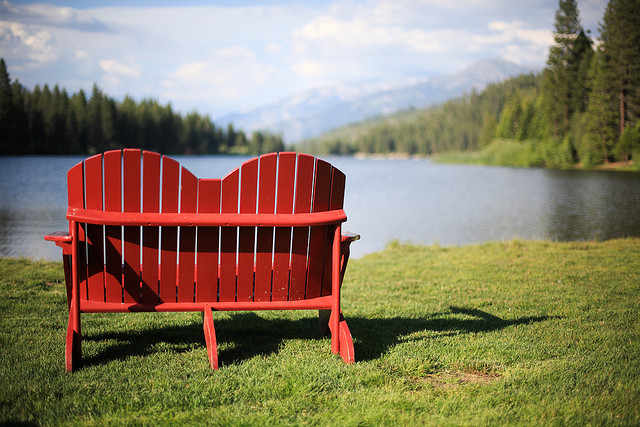How many people would fit on this bench? The bench can comfortably seat two people, providing a perfect spot for couples or friends to sit and enjoy the tranquil view of the lake and mountains. 